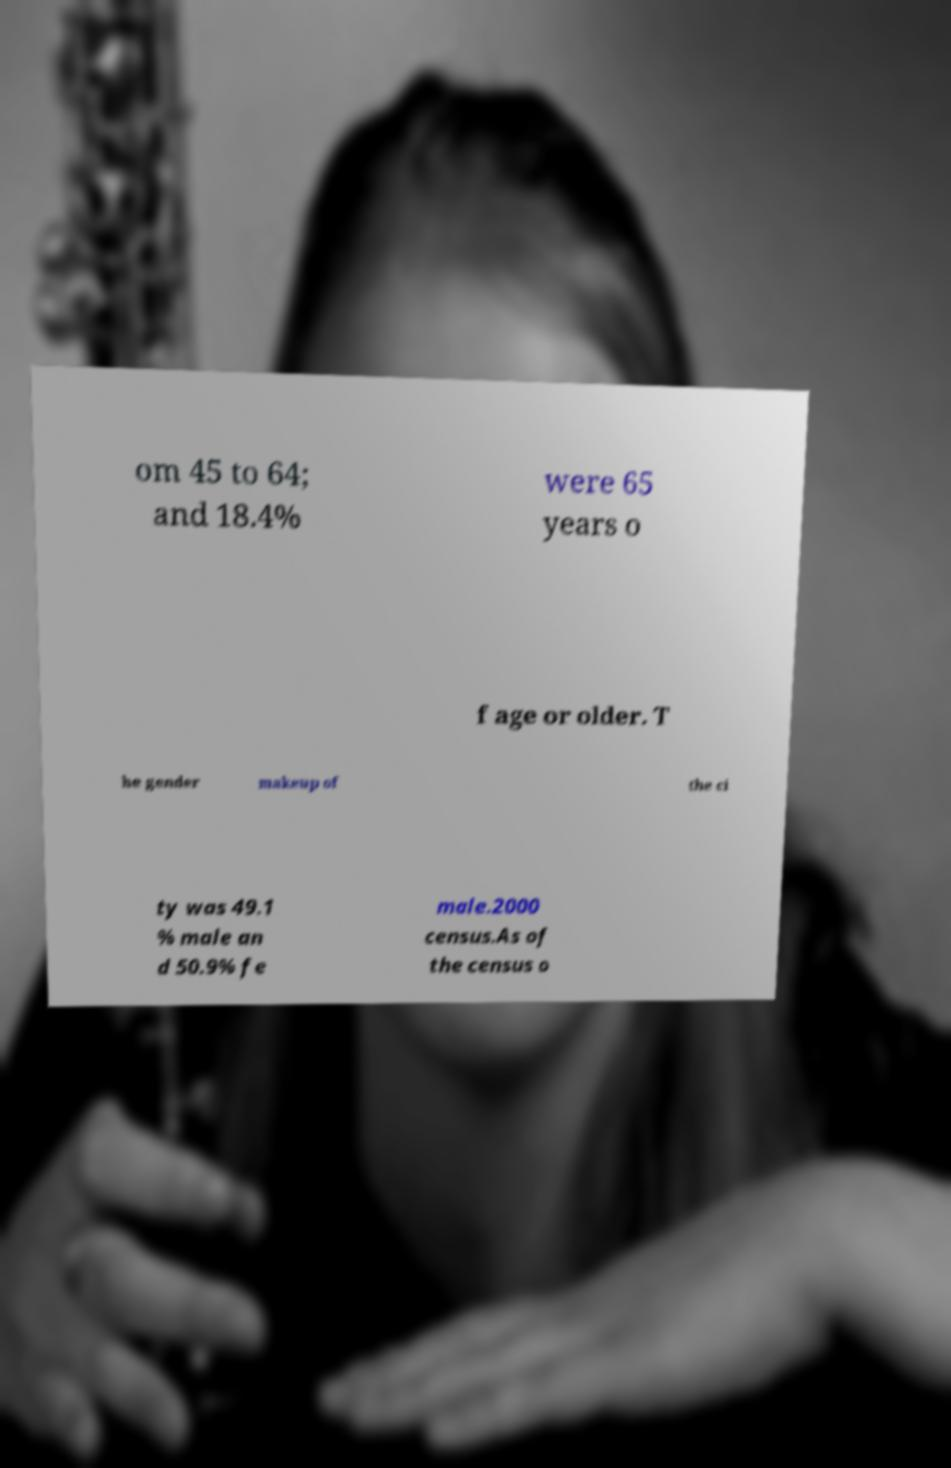Please read and relay the text visible in this image. What does it say? om 45 to 64; and 18.4% were 65 years o f age or older. T he gender makeup of the ci ty was 49.1 % male an d 50.9% fe male.2000 census.As of the census o 